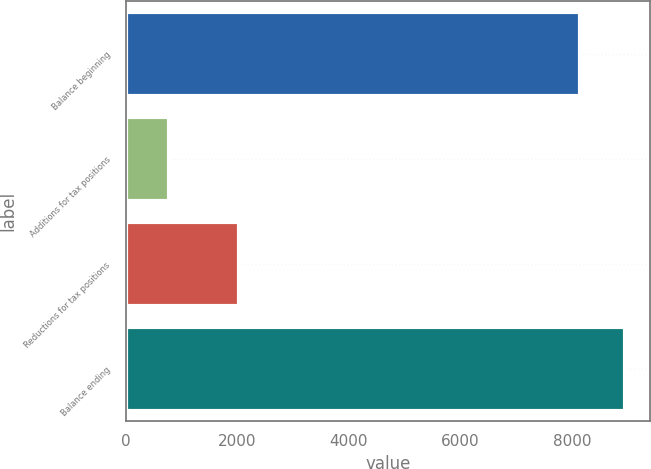Convert chart. <chart><loc_0><loc_0><loc_500><loc_500><bar_chart><fcel>Balance beginning<fcel>Additions for tax positions<fcel>Reductions for tax positions<fcel>Balance ending<nl><fcel>8138<fcel>786<fcel>2033<fcel>8953.7<nl></chart> 